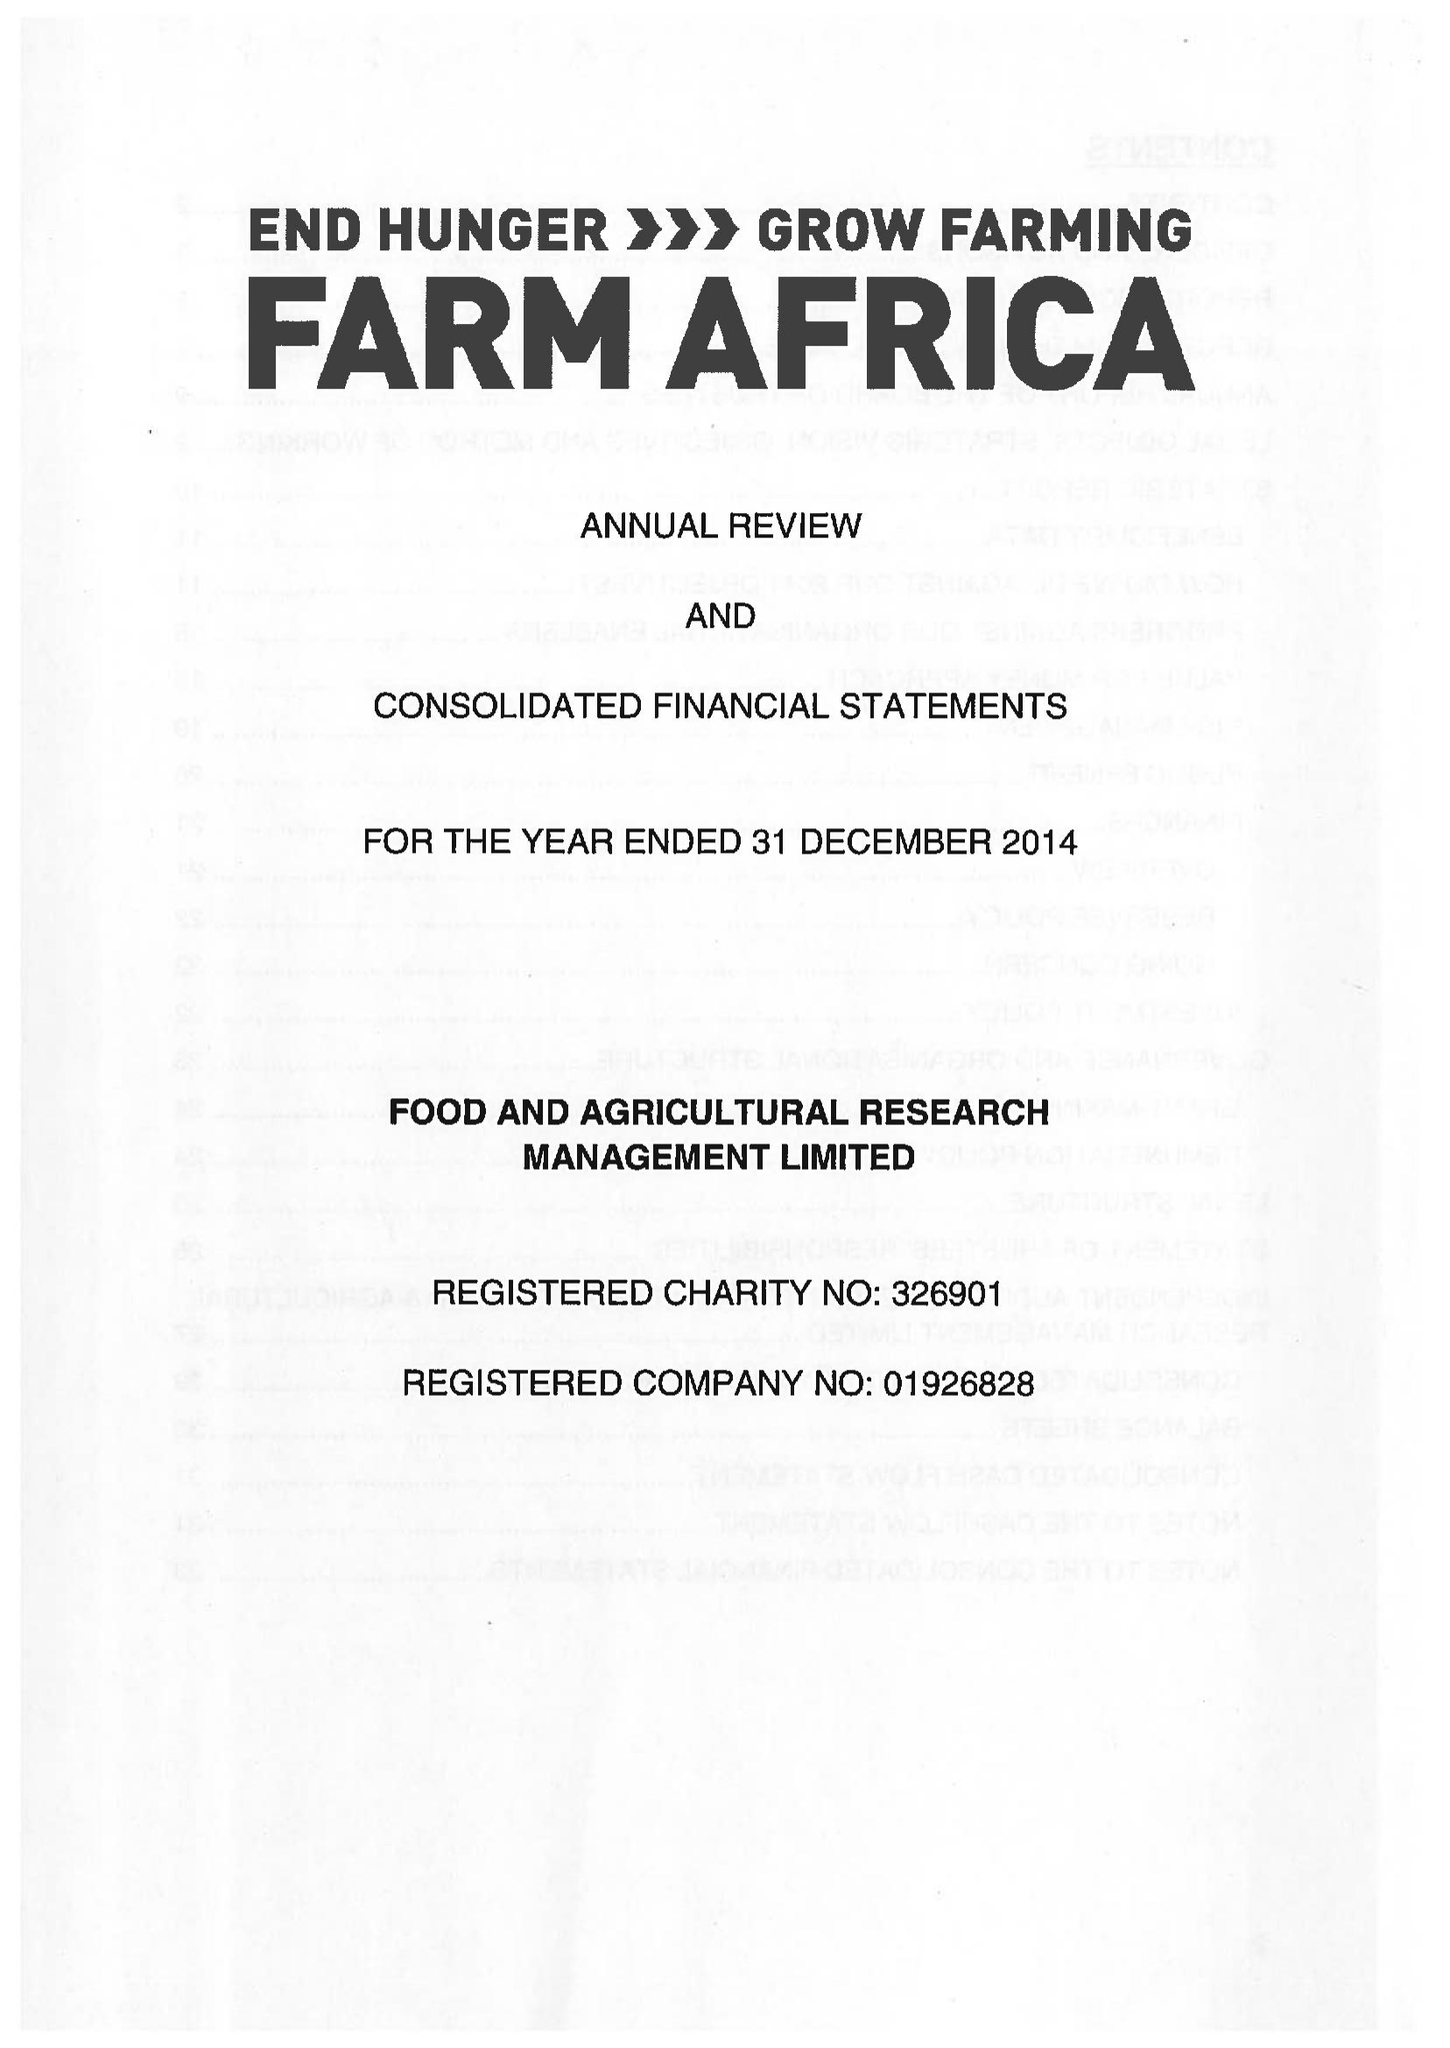What is the value for the address__street_line?
Answer the question using a single word or phrase. 140 LONDON WALL 